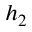Convert formula to latex. <formula><loc_0><loc_0><loc_500><loc_500>h _ { 2 }</formula> 